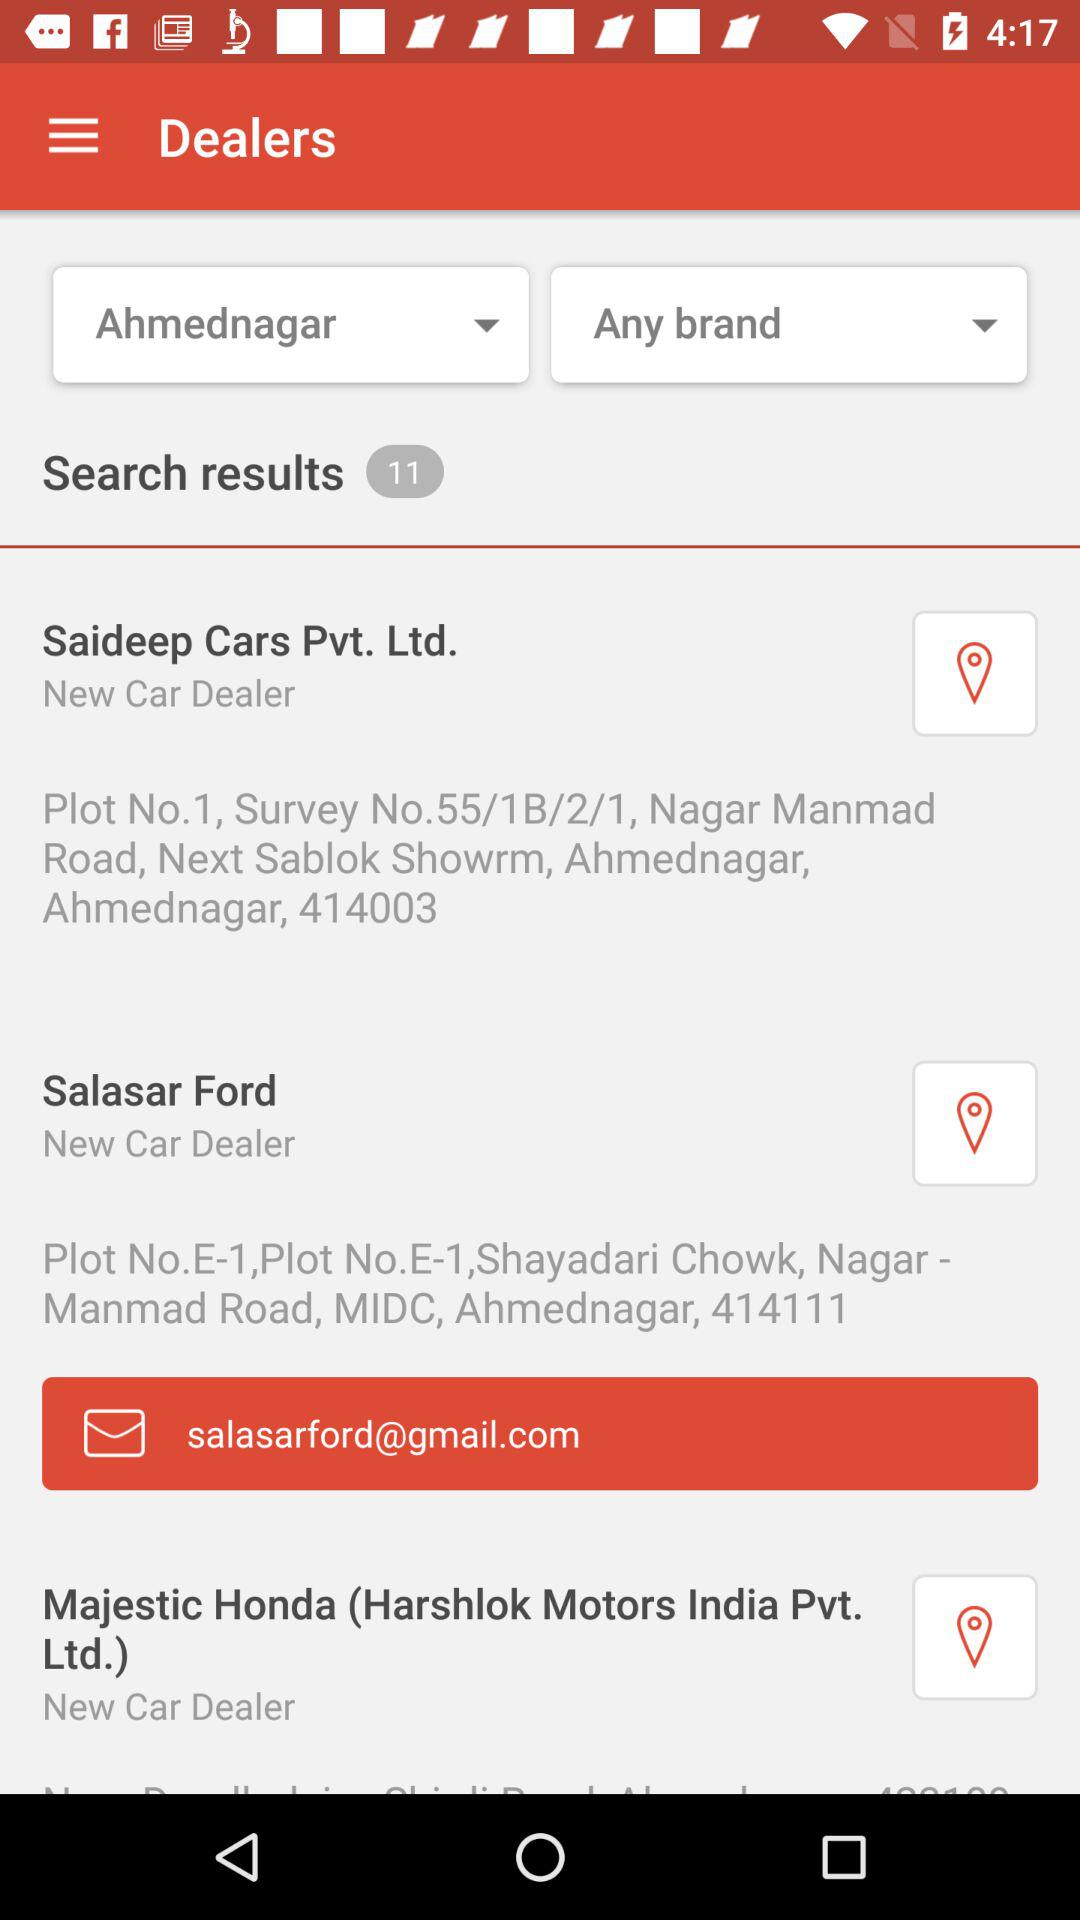What's the total number of search results? The total number of search results is 11. 